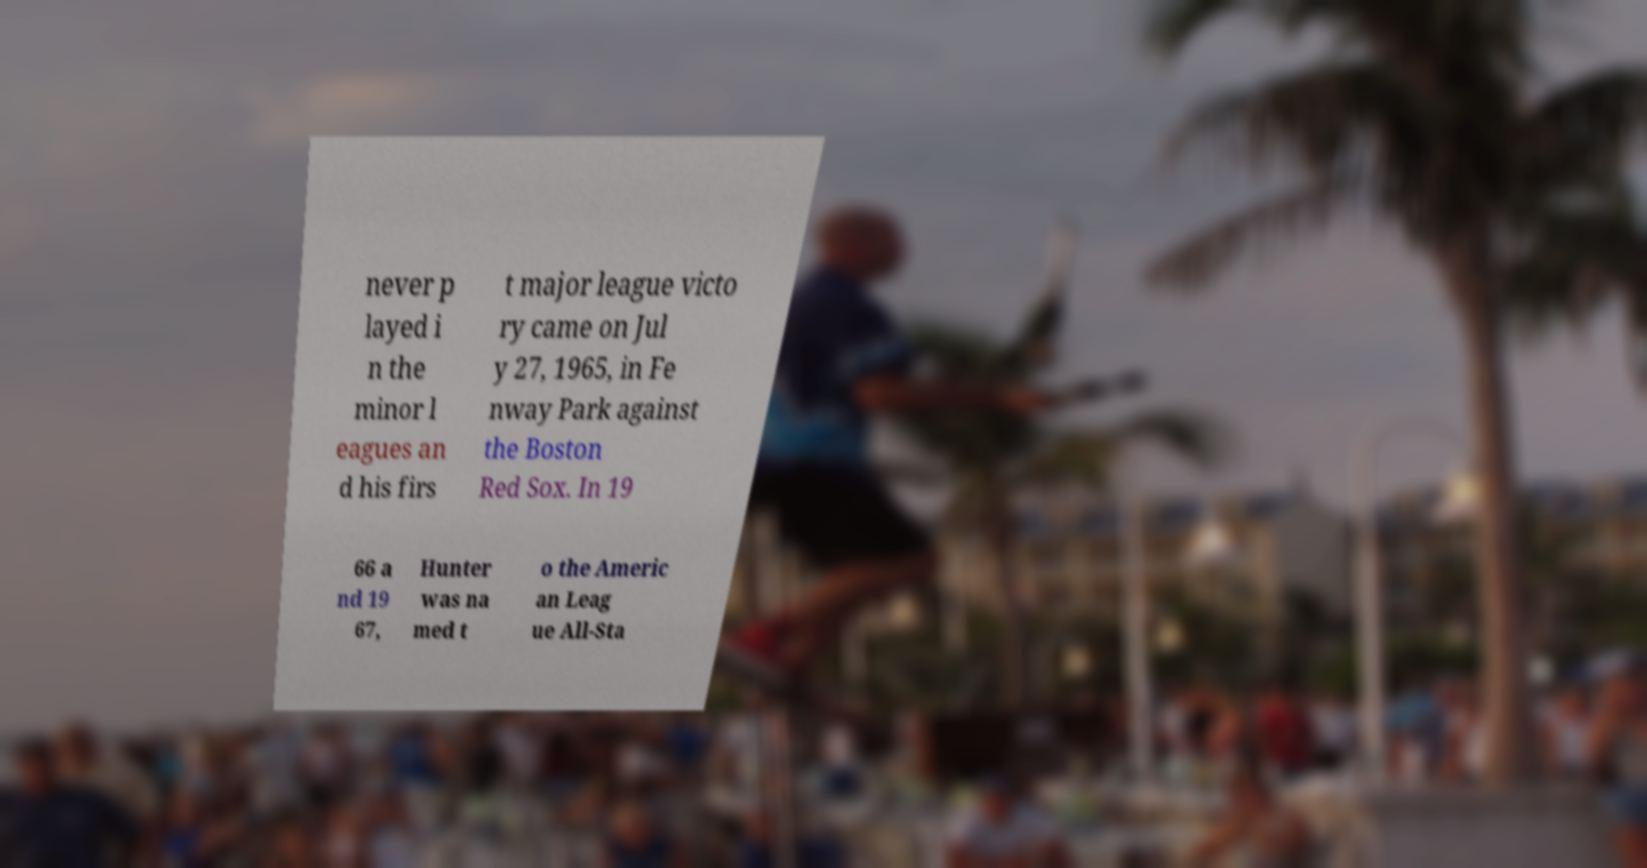Please read and relay the text visible in this image. What does it say? never p layed i n the minor l eagues an d his firs t major league victo ry came on Jul y 27, 1965, in Fe nway Park against the Boston Red Sox. In 19 66 a nd 19 67, Hunter was na med t o the Americ an Leag ue All-Sta 